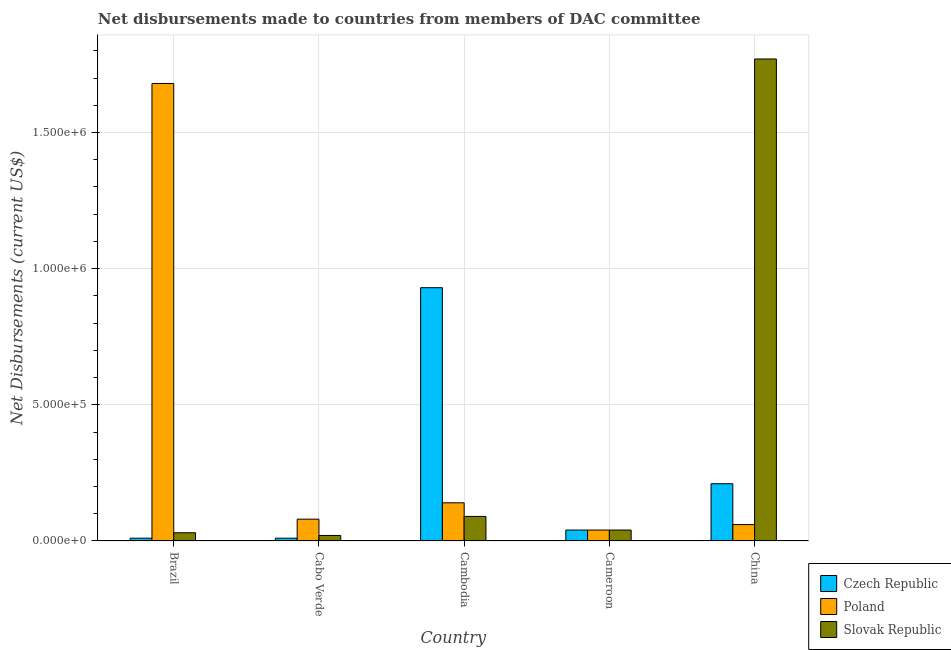How many different coloured bars are there?
Ensure brevity in your answer.  3. How many bars are there on the 3rd tick from the left?
Your answer should be very brief. 3. What is the label of the 3rd group of bars from the left?
Offer a very short reply. Cambodia. What is the net disbursements made by poland in Cambodia?
Keep it short and to the point. 1.40e+05. Across all countries, what is the maximum net disbursements made by czech republic?
Your answer should be very brief. 9.30e+05. Across all countries, what is the minimum net disbursements made by czech republic?
Provide a succinct answer. 10000. In which country was the net disbursements made by slovak republic minimum?
Your response must be concise. Cabo Verde. What is the total net disbursements made by czech republic in the graph?
Offer a very short reply. 1.20e+06. What is the difference between the net disbursements made by slovak republic in Cambodia and that in Cameroon?
Your response must be concise. 5.00e+04. What is the difference between the net disbursements made by slovak republic in Cambodia and the net disbursements made by poland in Cabo Verde?
Your answer should be very brief. 10000. What is the average net disbursements made by czech republic per country?
Ensure brevity in your answer.  2.40e+05. What is the difference between the net disbursements made by czech republic and net disbursements made by poland in Cabo Verde?
Give a very brief answer. -7.00e+04. In how many countries, is the net disbursements made by czech republic greater than 900000 US$?
Ensure brevity in your answer.  1. What is the ratio of the net disbursements made by czech republic in Brazil to that in Cabo Verde?
Give a very brief answer. 1. Is the net disbursements made by czech republic in Cambodia less than that in China?
Provide a succinct answer. No. What is the difference between the highest and the second highest net disbursements made by slovak republic?
Provide a succinct answer. 1.68e+06. What is the difference between the highest and the lowest net disbursements made by czech republic?
Your answer should be very brief. 9.20e+05. Is the sum of the net disbursements made by poland in Cameroon and China greater than the maximum net disbursements made by czech republic across all countries?
Offer a very short reply. No. What does the 1st bar from the left in Cabo Verde represents?
Make the answer very short. Czech Republic. What does the 3rd bar from the right in Brazil represents?
Your answer should be compact. Czech Republic. How many bars are there?
Provide a succinct answer. 15. Are all the bars in the graph horizontal?
Give a very brief answer. No. What is the difference between two consecutive major ticks on the Y-axis?
Your answer should be compact. 5.00e+05. Does the graph contain any zero values?
Make the answer very short. No. How many legend labels are there?
Your response must be concise. 3. What is the title of the graph?
Your response must be concise. Net disbursements made to countries from members of DAC committee. Does "Social insurance" appear as one of the legend labels in the graph?
Provide a succinct answer. No. What is the label or title of the Y-axis?
Make the answer very short. Net Disbursements (current US$). What is the Net Disbursements (current US$) of Czech Republic in Brazil?
Make the answer very short. 10000. What is the Net Disbursements (current US$) of Poland in Brazil?
Keep it short and to the point. 1.68e+06. What is the Net Disbursements (current US$) of Slovak Republic in Brazil?
Make the answer very short. 3.00e+04. What is the Net Disbursements (current US$) of Poland in Cabo Verde?
Give a very brief answer. 8.00e+04. What is the Net Disbursements (current US$) in Slovak Republic in Cabo Verde?
Keep it short and to the point. 2.00e+04. What is the Net Disbursements (current US$) in Czech Republic in Cambodia?
Give a very brief answer. 9.30e+05. What is the Net Disbursements (current US$) in Slovak Republic in Cameroon?
Provide a succinct answer. 4.00e+04. What is the Net Disbursements (current US$) in Czech Republic in China?
Provide a short and direct response. 2.10e+05. What is the Net Disbursements (current US$) in Poland in China?
Give a very brief answer. 6.00e+04. What is the Net Disbursements (current US$) of Slovak Republic in China?
Make the answer very short. 1.77e+06. Across all countries, what is the maximum Net Disbursements (current US$) in Czech Republic?
Your answer should be compact. 9.30e+05. Across all countries, what is the maximum Net Disbursements (current US$) in Poland?
Ensure brevity in your answer.  1.68e+06. Across all countries, what is the maximum Net Disbursements (current US$) of Slovak Republic?
Give a very brief answer. 1.77e+06. Across all countries, what is the minimum Net Disbursements (current US$) of Czech Republic?
Provide a short and direct response. 10000. Across all countries, what is the minimum Net Disbursements (current US$) in Poland?
Ensure brevity in your answer.  4.00e+04. Across all countries, what is the minimum Net Disbursements (current US$) of Slovak Republic?
Offer a terse response. 2.00e+04. What is the total Net Disbursements (current US$) of Czech Republic in the graph?
Provide a short and direct response. 1.20e+06. What is the total Net Disbursements (current US$) in Poland in the graph?
Your response must be concise. 2.00e+06. What is the total Net Disbursements (current US$) in Slovak Republic in the graph?
Provide a short and direct response. 1.95e+06. What is the difference between the Net Disbursements (current US$) in Poland in Brazil and that in Cabo Verde?
Give a very brief answer. 1.60e+06. What is the difference between the Net Disbursements (current US$) of Slovak Republic in Brazil and that in Cabo Verde?
Provide a succinct answer. 10000. What is the difference between the Net Disbursements (current US$) of Czech Republic in Brazil and that in Cambodia?
Provide a succinct answer. -9.20e+05. What is the difference between the Net Disbursements (current US$) in Poland in Brazil and that in Cambodia?
Provide a succinct answer. 1.54e+06. What is the difference between the Net Disbursements (current US$) of Slovak Republic in Brazil and that in Cambodia?
Your response must be concise. -6.00e+04. What is the difference between the Net Disbursements (current US$) of Czech Republic in Brazil and that in Cameroon?
Your response must be concise. -3.00e+04. What is the difference between the Net Disbursements (current US$) of Poland in Brazil and that in Cameroon?
Your answer should be very brief. 1.64e+06. What is the difference between the Net Disbursements (current US$) in Slovak Republic in Brazil and that in Cameroon?
Offer a terse response. -10000. What is the difference between the Net Disbursements (current US$) in Czech Republic in Brazil and that in China?
Your response must be concise. -2.00e+05. What is the difference between the Net Disbursements (current US$) of Poland in Brazil and that in China?
Give a very brief answer. 1.62e+06. What is the difference between the Net Disbursements (current US$) of Slovak Republic in Brazil and that in China?
Make the answer very short. -1.74e+06. What is the difference between the Net Disbursements (current US$) of Czech Republic in Cabo Verde and that in Cambodia?
Keep it short and to the point. -9.20e+05. What is the difference between the Net Disbursements (current US$) of Czech Republic in Cabo Verde and that in Cameroon?
Keep it short and to the point. -3.00e+04. What is the difference between the Net Disbursements (current US$) of Slovak Republic in Cabo Verde and that in Cameroon?
Give a very brief answer. -2.00e+04. What is the difference between the Net Disbursements (current US$) in Czech Republic in Cabo Verde and that in China?
Offer a very short reply. -2.00e+05. What is the difference between the Net Disbursements (current US$) of Slovak Republic in Cabo Verde and that in China?
Your answer should be compact. -1.75e+06. What is the difference between the Net Disbursements (current US$) in Czech Republic in Cambodia and that in Cameroon?
Ensure brevity in your answer.  8.90e+05. What is the difference between the Net Disbursements (current US$) in Poland in Cambodia and that in Cameroon?
Give a very brief answer. 1.00e+05. What is the difference between the Net Disbursements (current US$) of Slovak Republic in Cambodia and that in Cameroon?
Offer a very short reply. 5.00e+04. What is the difference between the Net Disbursements (current US$) of Czech Republic in Cambodia and that in China?
Your answer should be very brief. 7.20e+05. What is the difference between the Net Disbursements (current US$) in Poland in Cambodia and that in China?
Make the answer very short. 8.00e+04. What is the difference between the Net Disbursements (current US$) of Slovak Republic in Cambodia and that in China?
Your answer should be compact. -1.68e+06. What is the difference between the Net Disbursements (current US$) of Slovak Republic in Cameroon and that in China?
Your response must be concise. -1.73e+06. What is the difference between the Net Disbursements (current US$) in Czech Republic in Brazil and the Net Disbursements (current US$) in Poland in Cabo Verde?
Offer a terse response. -7.00e+04. What is the difference between the Net Disbursements (current US$) in Czech Republic in Brazil and the Net Disbursements (current US$) in Slovak Republic in Cabo Verde?
Your answer should be very brief. -10000. What is the difference between the Net Disbursements (current US$) in Poland in Brazil and the Net Disbursements (current US$) in Slovak Republic in Cabo Verde?
Offer a terse response. 1.66e+06. What is the difference between the Net Disbursements (current US$) in Czech Republic in Brazil and the Net Disbursements (current US$) in Poland in Cambodia?
Your answer should be very brief. -1.30e+05. What is the difference between the Net Disbursements (current US$) of Poland in Brazil and the Net Disbursements (current US$) of Slovak Republic in Cambodia?
Provide a short and direct response. 1.59e+06. What is the difference between the Net Disbursements (current US$) in Czech Republic in Brazil and the Net Disbursements (current US$) in Poland in Cameroon?
Make the answer very short. -3.00e+04. What is the difference between the Net Disbursements (current US$) in Poland in Brazil and the Net Disbursements (current US$) in Slovak Republic in Cameroon?
Give a very brief answer. 1.64e+06. What is the difference between the Net Disbursements (current US$) in Czech Republic in Brazil and the Net Disbursements (current US$) in Slovak Republic in China?
Make the answer very short. -1.76e+06. What is the difference between the Net Disbursements (current US$) in Poland in Brazil and the Net Disbursements (current US$) in Slovak Republic in China?
Ensure brevity in your answer.  -9.00e+04. What is the difference between the Net Disbursements (current US$) of Czech Republic in Cabo Verde and the Net Disbursements (current US$) of Poland in Cambodia?
Your answer should be compact. -1.30e+05. What is the difference between the Net Disbursements (current US$) of Czech Republic in Cabo Verde and the Net Disbursements (current US$) of Poland in Cameroon?
Give a very brief answer. -3.00e+04. What is the difference between the Net Disbursements (current US$) of Czech Republic in Cabo Verde and the Net Disbursements (current US$) of Slovak Republic in Cameroon?
Offer a terse response. -3.00e+04. What is the difference between the Net Disbursements (current US$) of Poland in Cabo Verde and the Net Disbursements (current US$) of Slovak Republic in Cameroon?
Keep it short and to the point. 4.00e+04. What is the difference between the Net Disbursements (current US$) of Czech Republic in Cabo Verde and the Net Disbursements (current US$) of Slovak Republic in China?
Your answer should be compact. -1.76e+06. What is the difference between the Net Disbursements (current US$) of Poland in Cabo Verde and the Net Disbursements (current US$) of Slovak Republic in China?
Your answer should be compact. -1.69e+06. What is the difference between the Net Disbursements (current US$) of Czech Republic in Cambodia and the Net Disbursements (current US$) of Poland in Cameroon?
Offer a very short reply. 8.90e+05. What is the difference between the Net Disbursements (current US$) in Czech Republic in Cambodia and the Net Disbursements (current US$) in Slovak Republic in Cameroon?
Offer a very short reply. 8.90e+05. What is the difference between the Net Disbursements (current US$) in Poland in Cambodia and the Net Disbursements (current US$) in Slovak Republic in Cameroon?
Provide a succinct answer. 1.00e+05. What is the difference between the Net Disbursements (current US$) in Czech Republic in Cambodia and the Net Disbursements (current US$) in Poland in China?
Make the answer very short. 8.70e+05. What is the difference between the Net Disbursements (current US$) of Czech Republic in Cambodia and the Net Disbursements (current US$) of Slovak Republic in China?
Make the answer very short. -8.40e+05. What is the difference between the Net Disbursements (current US$) in Poland in Cambodia and the Net Disbursements (current US$) in Slovak Republic in China?
Provide a short and direct response. -1.63e+06. What is the difference between the Net Disbursements (current US$) in Czech Republic in Cameroon and the Net Disbursements (current US$) in Slovak Republic in China?
Ensure brevity in your answer.  -1.73e+06. What is the difference between the Net Disbursements (current US$) of Poland in Cameroon and the Net Disbursements (current US$) of Slovak Republic in China?
Your response must be concise. -1.73e+06. What is the average Net Disbursements (current US$) of Poland per country?
Make the answer very short. 4.00e+05. What is the difference between the Net Disbursements (current US$) of Czech Republic and Net Disbursements (current US$) of Poland in Brazil?
Your response must be concise. -1.67e+06. What is the difference between the Net Disbursements (current US$) in Czech Republic and Net Disbursements (current US$) in Slovak Republic in Brazil?
Your answer should be very brief. -2.00e+04. What is the difference between the Net Disbursements (current US$) in Poland and Net Disbursements (current US$) in Slovak Republic in Brazil?
Provide a short and direct response. 1.65e+06. What is the difference between the Net Disbursements (current US$) in Czech Republic and Net Disbursements (current US$) in Slovak Republic in Cabo Verde?
Provide a succinct answer. -10000. What is the difference between the Net Disbursements (current US$) of Poland and Net Disbursements (current US$) of Slovak Republic in Cabo Verde?
Your response must be concise. 6.00e+04. What is the difference between the Net Disbursements (current US$) in Czech Republic and Net Disbursements (current US$) in Poland in Cambodia?
Offer a terse response. 7.90e+05. What is the difference between the Net Disbursements (current US$) of Czech Republic and Net Disbursements (current US$) of Slovak Republic in Cambodia?
Provide a short and direct response. 8.40e+05. What is the difference between the Net Disbursements (current US$) in Poland and Net Disbursements (current US$) in Slovak Republic in Cambodia?
Provide a succinct answer. 5.00e+04. What is the difference between the Net Disbursements (current US$) of Czech Republic and Net Disbursements (current US$) of Slovak Republic in China?
Provide a succinct answer. -1.56e+06. What is the difference between the Net Disbursements (current US$) in Poland and Net Disbursements (current US$) in Slovak Republic in China?
Offer a terse response. -1.71e+06. What is the ratio of the Net Disbursements (current US$) of Czech Republic in Brazil to that in Cabo Verde?
Your answer should be compact. 1. What is the ratio of the Net Disbursements (current US$) in Slovak Republic in Brazil to that in Cabo Verde?
Make the answer very short. 1.5. What is the ratio of the Net Disbursements (current US$) of Czech Republic in Brazil to that in Cambodia?
Ensure brevity in your answer.  0.01. What is the ratio of the Net Disbursements (current US$) in Poland in Brazil to that in Cambodia?
Your answer should be very brief. 12. What is the ratio of the Net Disbursements (current US$) of Poland in Brazil to that in Cameroon?
Give a very brief answer. 42. What is the ratio of the Net Disbursements (current US$) in Slovak Republic in Brazil to that in Cameroon?
Provide a short and direct response. 0.75. What is the ratio of the Net Disbursements (current US$) in Czech Republic in Brazil to that in China?
Give a very brief answer. 0.05. What is the ratio of the Net Disbursements (current US$) in Slovak Republic in Brazil to that in China?
Your response must be concise. 0.02. What is the ratio of the Net Disbursements (current US$) of Czech Republic in Cabo Verde to that in Cambodia?
Ensure brevity in your answer.  0.01. What is the ratio of the Net Disbursements (current US$) in Slovak Republic in Cabo Verde to that in Cambodia?
Provide a short and direct response. 0.22. What is the ratio of the Net Disbursements (current US$) in Czech Republic in Cabo Verde to that in Cameroon?
Offer a terse response. 0.25. What is the ratio of the Net Disbursements (current US$) of Slovak Republic in Cabo Verde to that in Cameroon?
Offer a very short reply. 0.5. What is the ratio of the Net Disbursements (current US$) in Czech Republic in Cabo Verde to that in China?
Your answer should be compact. 0.05. What is the ratio of the Net Disbursements (current US$) of Poland in Cabo Verde to that in China?
Ensure brevity in your answer.  1.33. What is the ratio of the Net Disbursements (current US$) in Slovak Republic in Cabo Verde to that in China?
Ensure brevity in your answer.  0.01. What is the ratio of the Net Disbursements (current US$) in Czech Republic in Cambodia to that in Cameroon?
Your response must be concise. 23.25. What is the ratio of the Net Disbursements (current US$) of Slovak Republic in Cambodia to that in Cameroon?
Provide a short and direct response. 2.25. What is the ratio of the Net Disbursements (current US$) of Czech Republic in Cambodia to that in China?
Your answer should be very brief. 4.43. What is the ratio of the Net Disbursements (current US$) of Poland in Cambodia to that in China?
Ensure brevity in your answer.  2.33. What is the ratio of the Net Disbursements (current US$) in Slovak Republic in Cambodia to that in China?
Give a very brief answer. 0.05. What is the ratio of the Net Disbursements (current US$) of Czech Republic in Cameroon to that in China?
Offer a terse response. 0.19. What is the ratio of the Net Disbursements (current US$) of Slovak Republic in Cameroon to that in China?
Your answer should be very brief. 0.02. What is the difference between the highest and the second highest Net Disbursements (current US$) of Czech Republic?
Give a very brief answer. 7.20e+05. What is the difference between the highest and the second highest Net Disbursements (current US$) in Poland?
Ensure brevity in your answer.  1.54e+06. What is the difference between the highest and the second highest Net Disbursements (current US$) in Slovak Republic?
Your response must be concise. 1.68e+06. What is the difference between the highest and the lowest Net Disbursements (current US$) in Czech Republic?
Ensure brevity in your answer.  9.20e+05. What is the difference between the highest and the lowest Net Disbursements (current US$) in Poland?
Your response must be concise. 1.64e+06. What is the difference between the highest and the lowest Net Disbursements (current US$) of Slovak Republic?
Keep it short and to the point. 1.75e+06. 